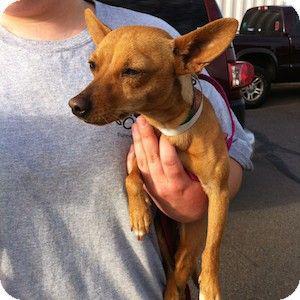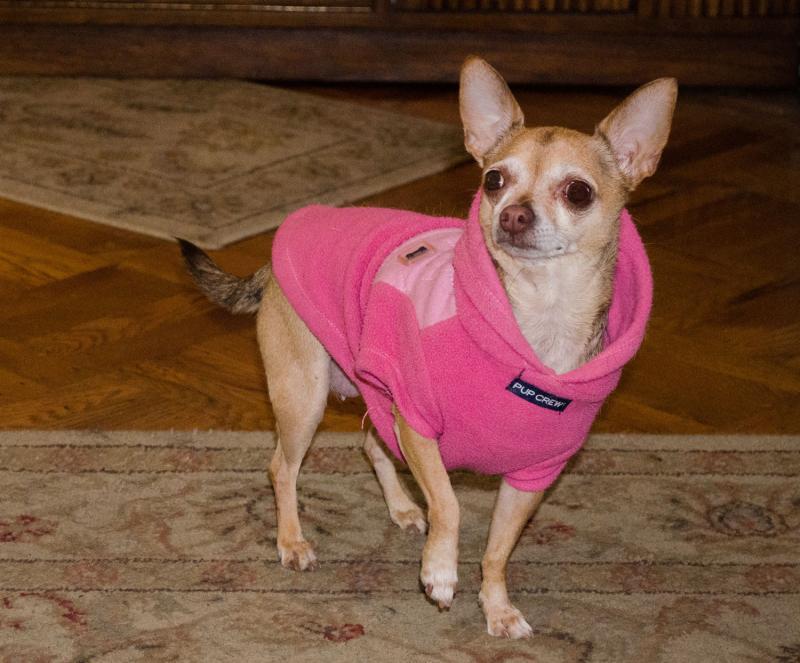The first image is the image on the left, the second image is the image on the right. Evaluate the accuracy of this statement regarding the images: "One image shows one tan dog wearing a collar, and the other image includes at least one chihuahua wearing something hot pink.". Is it true? Answer yes or no. Yes. The first image is the image on the left, the second image is the image on the right. For the images displayed, is the sentence "There are four dogs in one image and the other has only one." factually correct? Answer yes or no. No. 